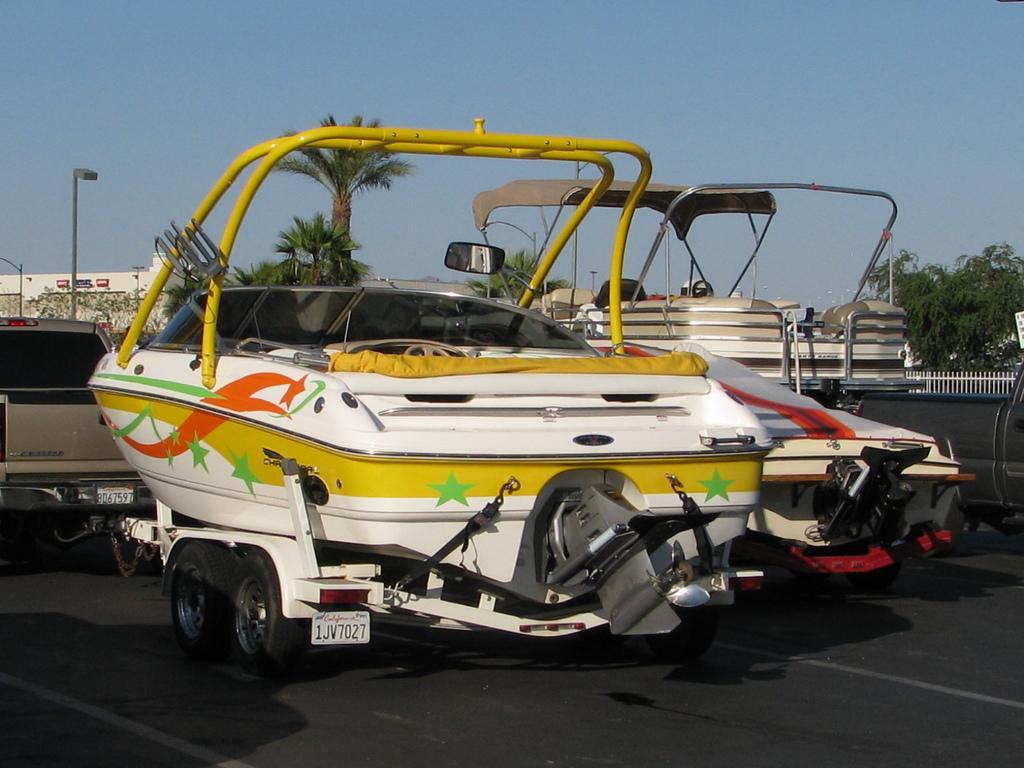Please provide a concise description of this image. There are vehicles, trees, fencing, poles and buildings at the back. 